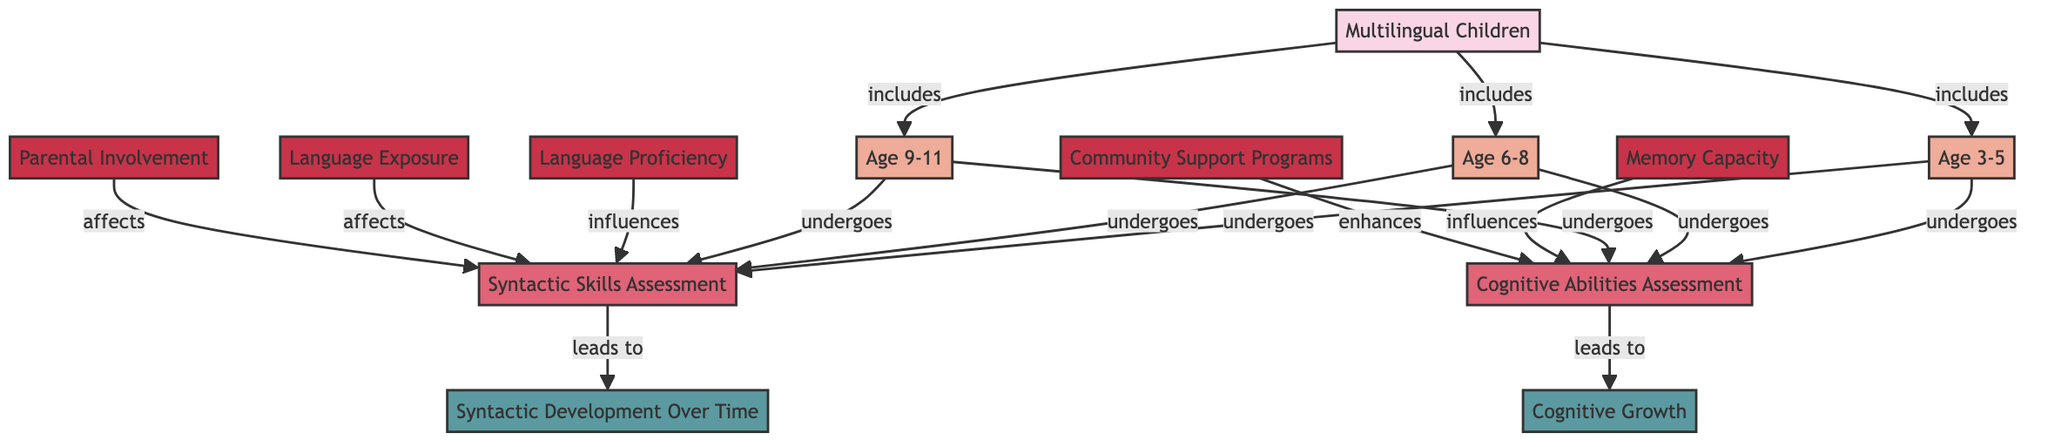What age groups are included in the study? The diagram lists three age groups: Age 3-5, Age 6-8, and Age 9-11 as part of the node that represents Multilingual Children.
Answer: Age 3-5, Age 6-8, Age 9-11 What assessments do children undergo at Age 6-8? The diagram shows that children in the Age 6-8 group undergo both Syntactic Skills Assessment and Cognitive Abilities Assessment, as represented by the arrows pointing to these processes from the node of Age 6-8.
Answer: Syntactic Skills Assessment, Cognitive Abilities Assessment How many attributes influence Syntactic Skills Assessment? The diagram indicates that there are four attributes (Language Proficiency, Memory Capacity, Language Exposure, and Parental Involvement) that influence Syntactic Skills Assessment. Each attribute is connected to the Syntactic Skills Assessment node.
Answer: 4 What outcomes are linked to the assessments? The diagram shows that Syntactic Skills Assessment leads to Syntactic Development Over Time, while Cognitive Abilities Assessment leads to Cognitive Growth. This is represented by the directed arrows from the assessment nodes to the outcomes.
Answer: Syntactic Development Over Time, Cognitive Growth Which factor enhances Cognitive Abilities Assessment? According to the diagram, Community Support Programs is the only factor that enhances Cognitive Abilities Assessment, as it is the only attribute connected by an enhancing arrow to the process of Cognitive Abilities Assessment.
Answer: Community Support Programs What is the relationship between Language Exposure and Syntactic Skills Assessment? The diagram indicates that Language Exposure affects Syntactic Skills Assessment, meaning it has some influence on the process of assessing syntactic skills, which is represented by an affecting relationship in the diagram.
Answer: Affects How many nodes represent age groups in the study? The diagram shows three distinct age groups represented by nodes: Age 3-5, Age 6-8, and Age 9-11, demonstrating diversity in the groups being studied. By counting these nodes, we determine the total.
Answer: 3 Which assessment leads to Cognitive Growth? The diagram clearly indicates that Cognitive Abilities Assessment leads to Cognitive Growth, as seen in the directed arrow pointing from the Cognitive Abilities Assessment node to the Cognitive Growth outcome node.
Answer: Cognitive Abilities Assessment 